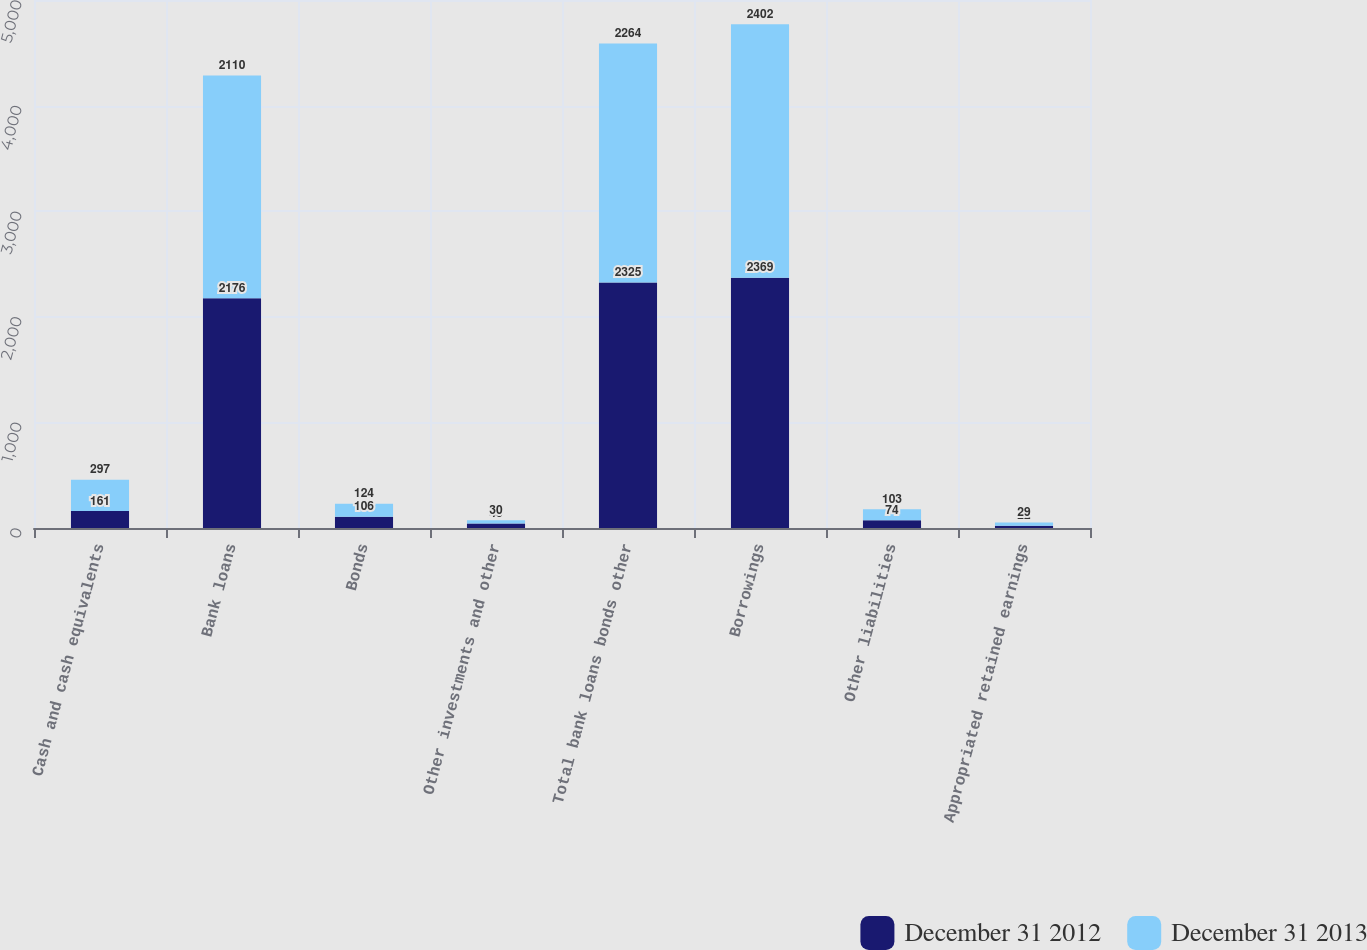Convert chart to OTSL. <chart><loc_0><loc_0><loc_500><loc_500><stacked_bar_chart><ecel><fcel>Cash and cash equivalents<fcel>Bank loans<fcel>Bonds<fcel>Other investments and other<fcel>Total bank loans bonds other<fcel>Borrowings<fcel>Other liabilities<fcel>Appropriated retained earnings<nl><fcel>December 31 2012<fcel>161<fcel>2176<fcel>106<fcel>43<fcel>2325<fcel>2369<fcel>74<fcel>22<nl><fcel>December 31 2013<fcel>297<fcel>2110<fcel>124<fcel>30<fcel>2264<fcel>2402<fcel>103<fcel>29<nl></chart> 